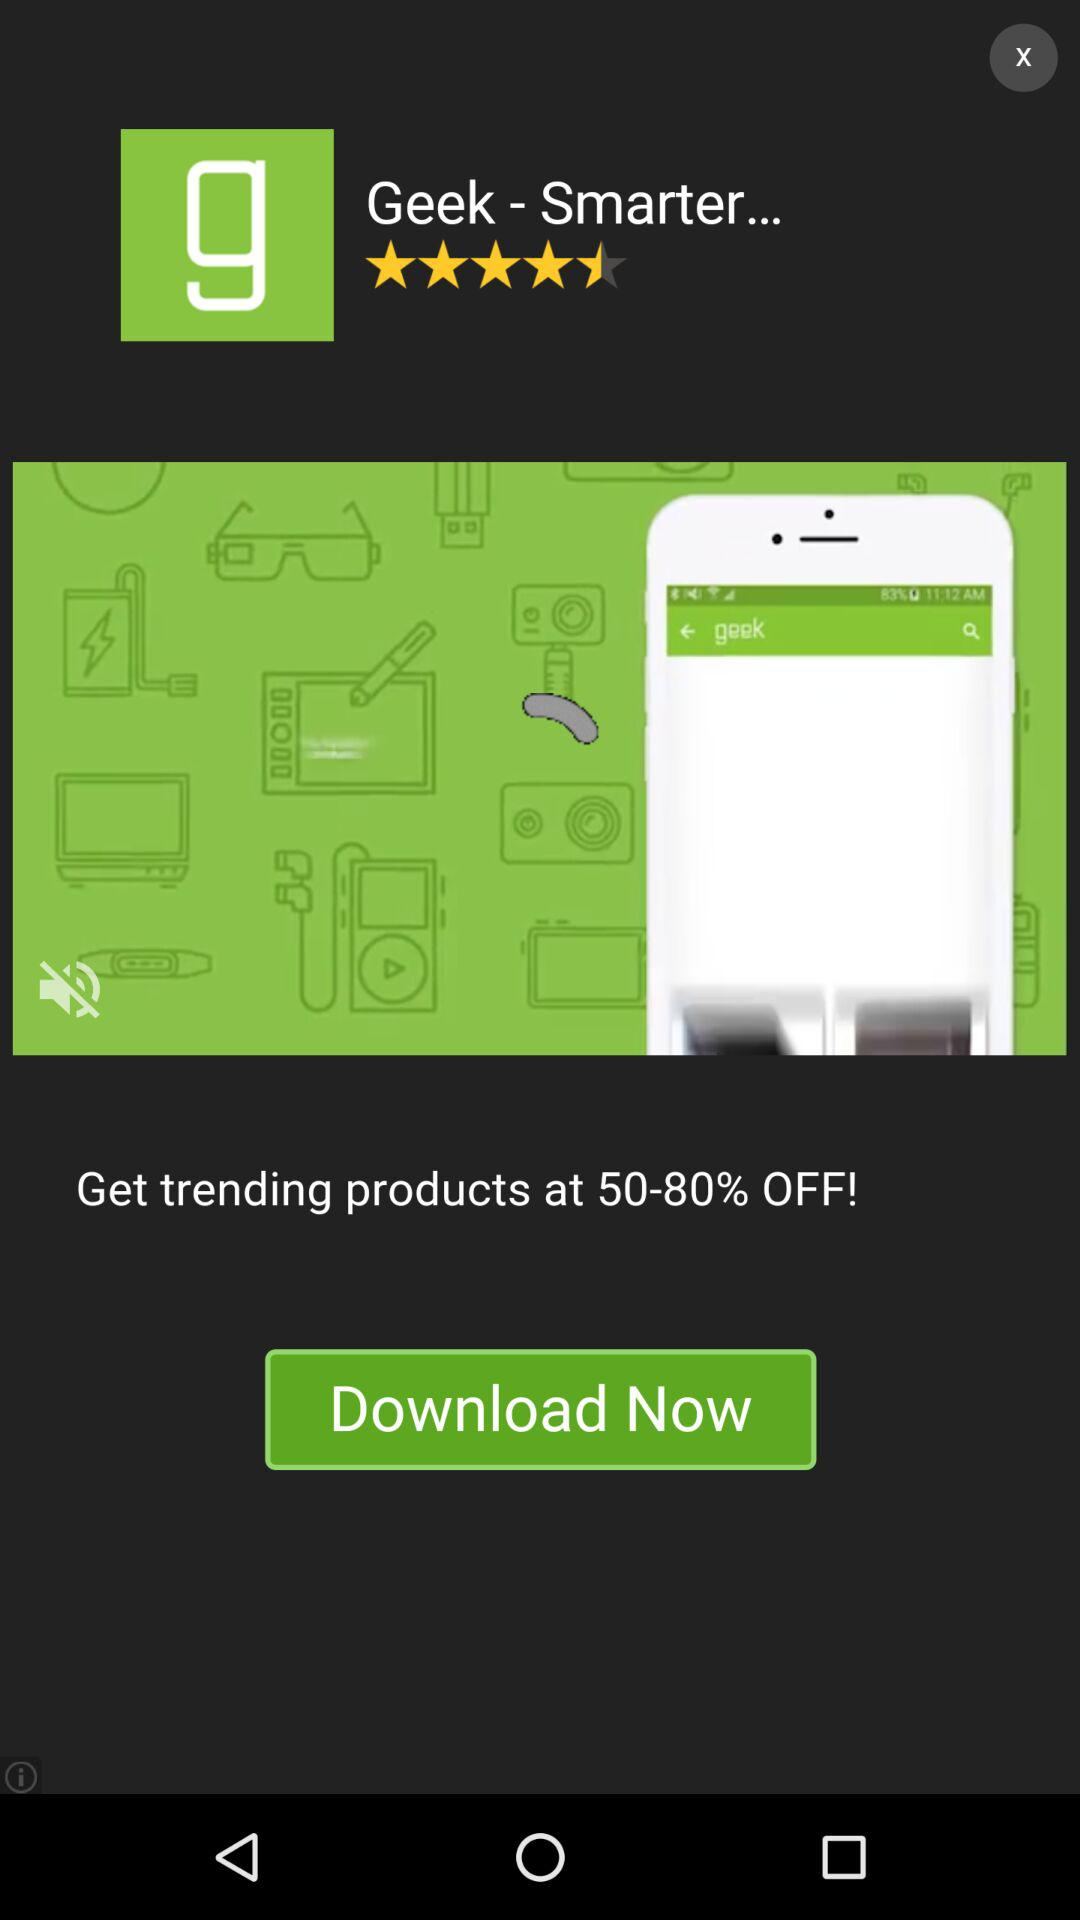How many percent discount is offered?
Answer the question using a single word or phrase. 50-80% 